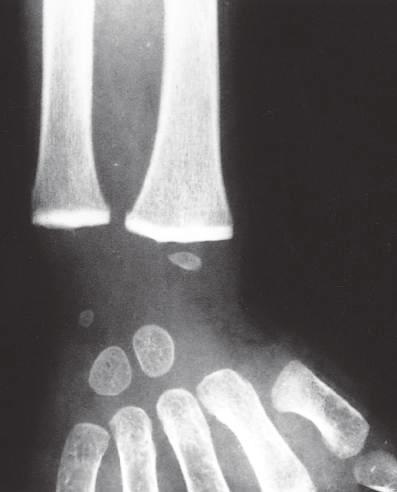what has caused a marked increase in their radiodensity, so that they are as radiopaque as the cortical bone?
Answer the question using a single word or phrase. Impaired remodeling of calcified cartilage in the epiphyses (arrows) of the wrist 